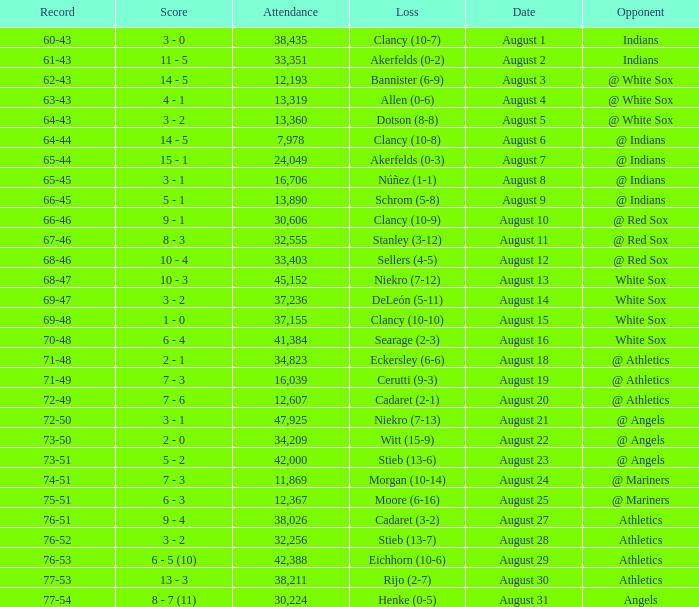What was the attendance when the record was 77-54? 30224.0. 